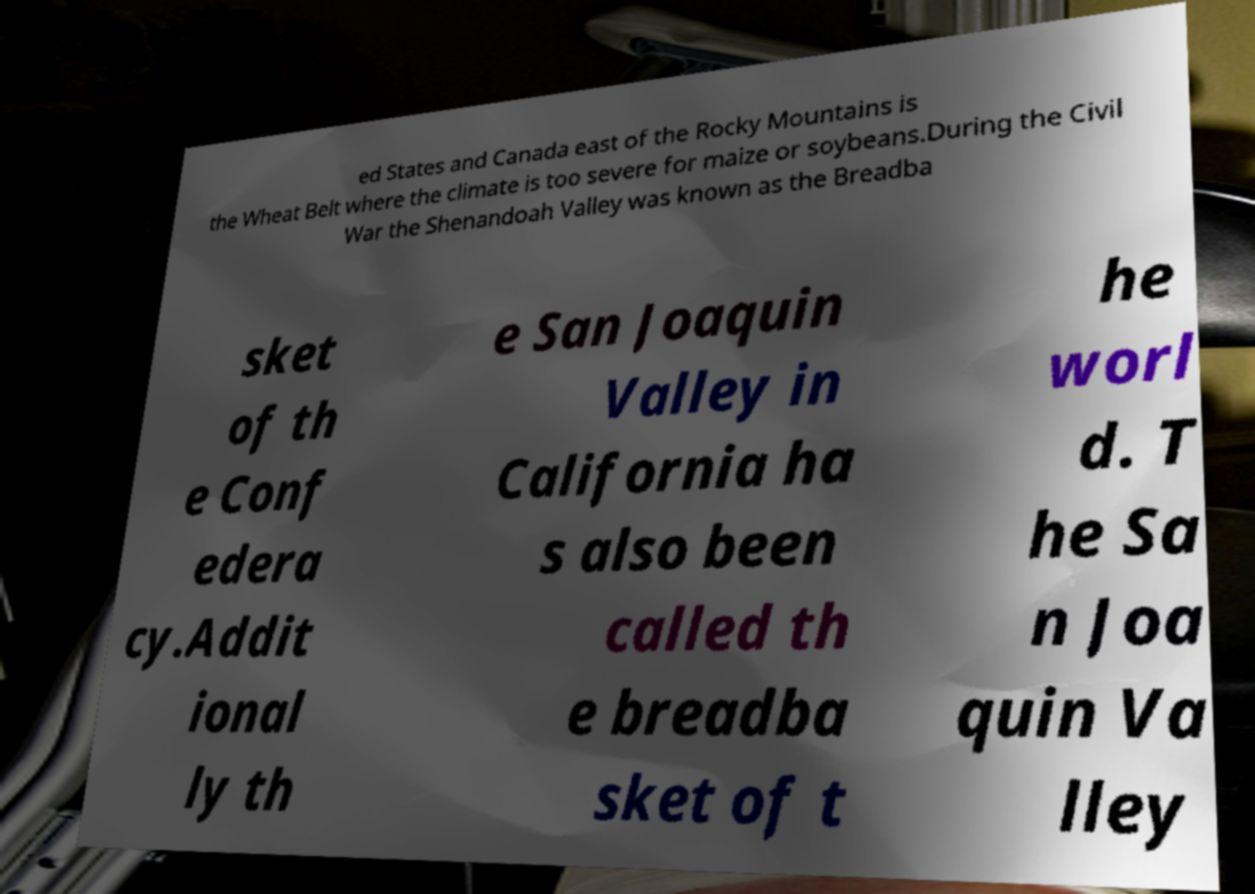For documentation purposes, I need the text within this image transcribed. Could you provide that? ed States and Canada east of the Rocky Mountains is the Wheat Belt where the climate is too severe for maize or soybeans.During the Civil War the Shenandoah Valley was known as the Breadba sket of th e Conf edera cy.Addit ional ly th e San Joaquin Valley in California ha s also been called th e breadba sket of t he worl d. T he Sa n Joa quin Va lley 